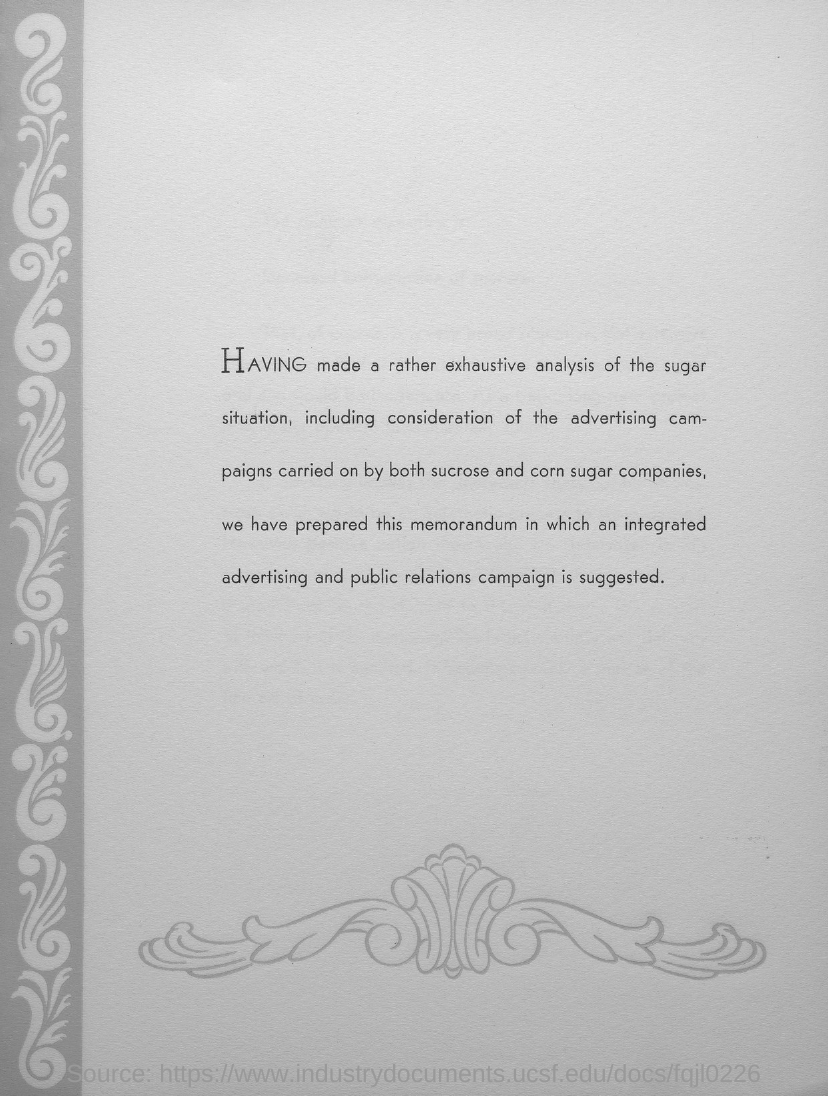Specify some key components in this picture. The word that is written in capital letters is 'HAVING'. 